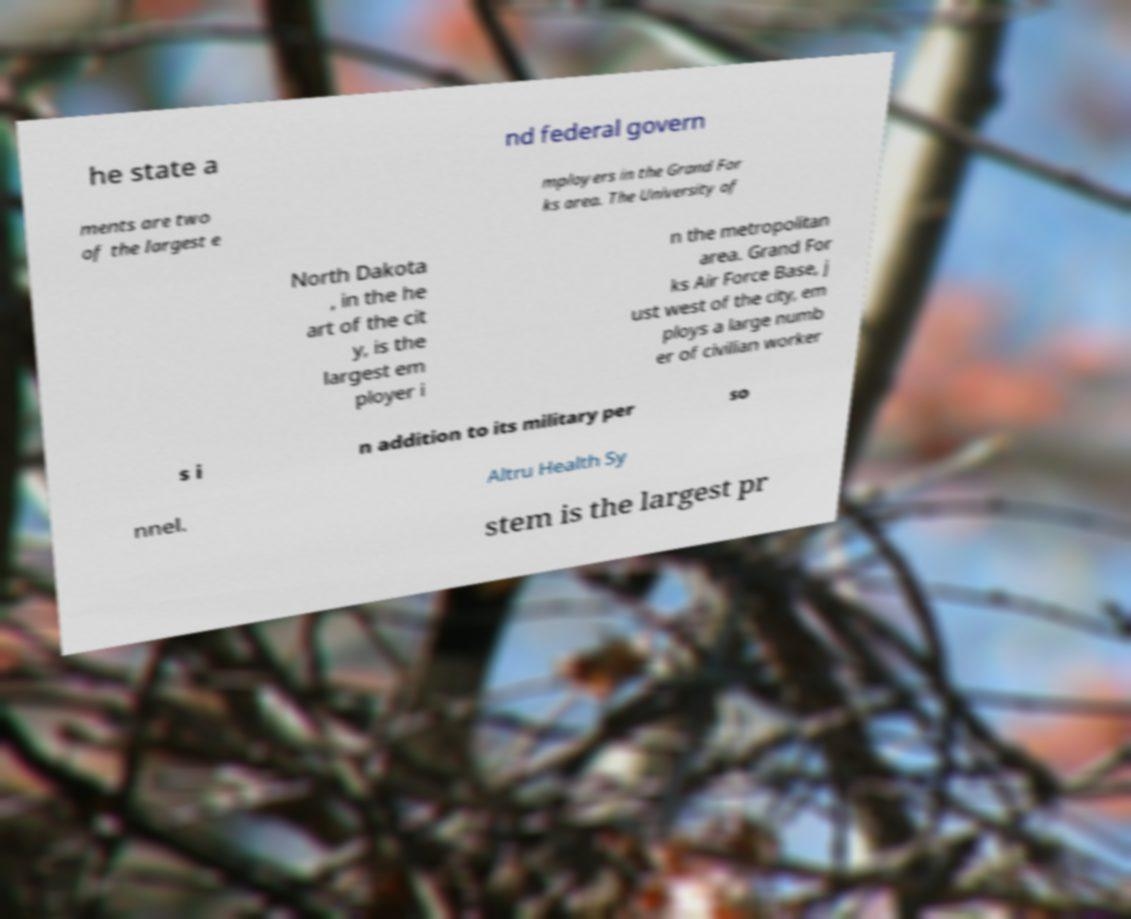Please identify and transcribe the text found in this image. he state a nd federal govern ments are two of the largest e mployers in the Grand For ks area. The University of North Dakota , in the he art of the cit y, is the largest em ployer i n the metropolitan area. Grand For ks Air Force Base, j ust west of the city, em ploys a large numb er of civilian worker s i n addition to its military per so nnel. Altru Health Sy stem is the largest pr 